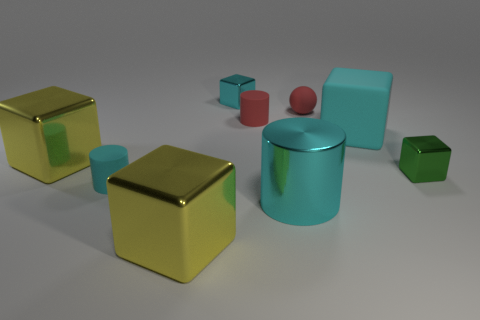Subtract all small cyan metallic cubes. How many cubes are left? 4 Subtract all green blocks. How many blocks are left? 4 Subtract all purple cubes. Subtract all green balls. How many cubes are left? 5 Add 1 cyan metal objects. How many objects exist? 10 Subtract all cubes. How many objects are left? 4 Subtract all large rubber things. Subtract all red matte objects. How many objects are left? 6 Add 2 small green shiny cubes. How many small green shiny cubes are left? 3 Add 1 big purple metallic things. How many big purple metallic things exist? 1 Subtract 0 yellow spheres. How many objects are left? 9 